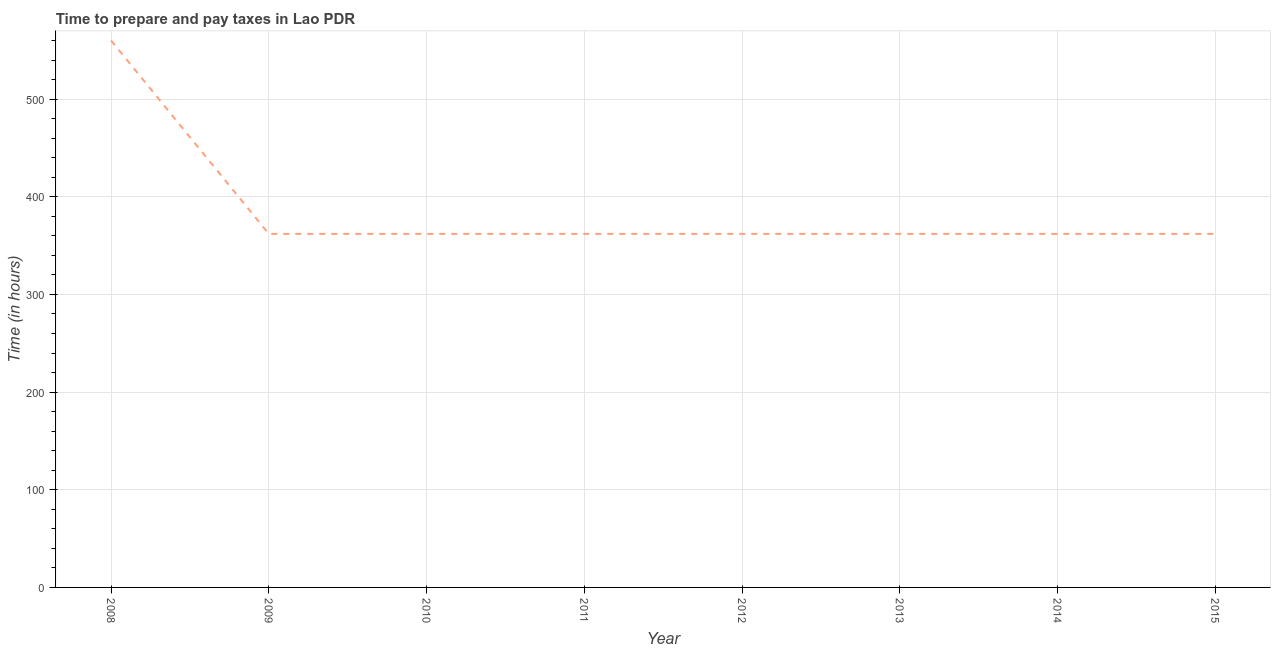What is the time to prepare and pay taxes in 2013?
Offer a very short reply. 362. Across all years, what is the maximum time to prepare and pay taxes?
Make the answer very short. 560. Across all years, what is the minimum time to prepare and pay taxes?
Offer a very short reply. 362. In which year was the time to prepare and pay taxes maximum?
Your answer should be very brief. 2008. What is the sum of the time to prepare and pay taxes?
Make the answer very short. 3094. What is the difference between the time to prepare and pay taxes in 2008 and 2014?
Ensure brevity in your answer.  198. What is the average time to prepare and pay taxes per year?
Offer a very short reply. 386.75. What is the median time to prepare and pay taxes?
Provide a succinct answer. 362. In how many years, is the time to prepare and pay taxes greater than 80 hours?
Your answer should be very brief. 8. What is the ratio of the time to prepare and pay taxes in 2008 to that in 2010?
Provide a short and direct response. 1.55. Is the difference between the time to prepare and pay taxes in 2013 and 2015 greater than the difference between any two years?
Offer a terse response. No. What is the difference between the highest and the second highest time to prepare and pay taxes?
Provide a succinct answer. 198. Is the sum of the time to prepare and pay taxes in 2012 and 2013 greater than the maximum time to prepare and pay taxes across all years?
Offer a very short reply. Yes. What is the difference between the highest and the lowest time to prepare and pay taxes?
Provide a succinct answer. 198. How many years are there in the graph?
Your answer should be very brief. 8. What is the difference between two consecutive major ticks on the Y-axis?
Your answer should be compact. 100. Are the values on the major ticks of Y-axis written in scientific E-notation?
Your response must be concise. No. Does the graph contain grids?
Provide a succinct answer. Yes. What is the title of the graph?
Ensure brevity in your answer.  Time to prepare and pay taxes in Lao PDR. What is the label or title of the Y-axis?
Your answer should be very brief. Time (in hours). What is the Time (in hours) of 2008?
Your response must be concise. 560. What is the Time (in hours) in 2009?
Make the answer very short. 362. What is the Time (in hours) in 2010?
Your response must be concise. 362. What is the Time (in hours) in 2011?
Provide a short and direct response. 362. What is the Time (in hours) of 2012?
Your answer should be very brief. 362. What is the Time (in hours) of 2013?
Keep it short and to the point. 362. What is the Time (in hours) in 2014?
Provide a succinct answer. 362. What is the Time (in hours) of 2015?
Ensure brevity in your answer.  362. What is the difference between the Time (in hours) in 2008 and 2009?
Your response must be concise. 198. What is the difference between the Time (in hours) in 2008 and 2010?
Provide a short and direct response. 198. What is the difference between the Time (in hours) in 2008 and 2011?
Keep it short and to the point. 198. What is the difference between the Time (in hours) in 2008 and 2012?
Provide a succinct answer. 198. What is the difference between the Time (in hours) in 2008 and 2013?
Offer a very short reply. 198. What is the difference between the Time (in hours) in 2008 and 2014?
Your answer should be very brief. 198. What is the difference between the Time (in hours) in 2008 and 2015?
Make the answer very short. 198. What is the difference between the Time (in hours) in 2009 and 2010?
Make the answer very short. 0. What is the difference between the Time (in hours) in 2009 and 2013?
Provide a succinct answer. 0. What is the difference between the Time (in hours) in 2009 and 2014?
Your answer should be compact. 0. What is the difference between the Time (in hours) in 2010 and 2011?
Your response must be concise. 0. What is the difference between the Time (in hours) in 2010 and 2014?
Make the answer very short. 0. What is the difference between the Time (in hours) in 2010 and 2015?
Make the answer very short. 0. What is the difference between the Time (in hours) in 2011 and 2012?
Provide a short and direct response. 0. What is the difference between the Time (in hours) in 2011 and 2015?
Provide a succinct answer. 0. What is the difference between the Time (in hours) in 2012 and 2014?
Offer a very short reply. 0. What is the difference between the Time (in hours) in 2012 and 2015?
Your response must be concise. 0. What is the difference between the Time (in hours) in 2013 and 2014?
Your answer should be compact. 0. What is the difference between the Time (in hours) in 2013 and 2015?
Provide a short and direct response. 0. What is the difference between the Time (in hours) in 2014 and 2015?
Make the answer very short. 0. What is the ratio of the Time (in hours) in 2008 to that in 2009?
Make the answer very short. 1.55. What is the ratio of the Time (in hours) in 2008 to that in 2010?
Provide a short and direct response. 1.55. What is the ratio of the Time (in hours) in 2008 to that in 2011?
Offer a terse response. 1.55. What is the ratio of the Time (in hours) in 2008 to that in 2012?
Give a very brief answer. 1.55. What is the ratio of the Time (in hours) in 2008 to that in 2013?
Provide a short and direct response. 1.55. What is the ratio of the Time (in hours) in 2008 to that in 2014?
Your answer should be compact. 1.55. What is the ratio of the Time (in hours) in 2008 to that in 2015?
Provide a short and direct response. 1.55. What is the ratio of the Time (in hours) in 2009 to that in 2012?
Your answer should be very brief. 1. What is the ratio of the Time (in hours) in 2009 to that in 2014?
Keep it short and to the point. 1. What is the ratio of the Time (in hours) in 2009 to that in 2015?
Make the answer very short. 1. What is the ratio of the Time (in hours) in 2010 to that in 2011?
Your answer should be compact. 1. What is the ratio of the Time (in hours) in 2010 to that in 2012?
Provide a succinct answer. 1. What is the ratio of the Time (in hours) in 2010 to that in 2015?
Offer a very short reply. 1. What is the ratio of the Time (in hours) in 2011 to that in 2013?
Keep it short and to the point. 1. What is the ratio of the Time (in hours) in 2012 to that in 2013?
Your response must be concise. 1. What is the ratio of the Time (in hours) in 2012 to that in 2014?
Provide a short and direct response. 1. What is the ratio of the Time (in hours) in 2012 to that in 2015?
Offer a very short reply. 1. 